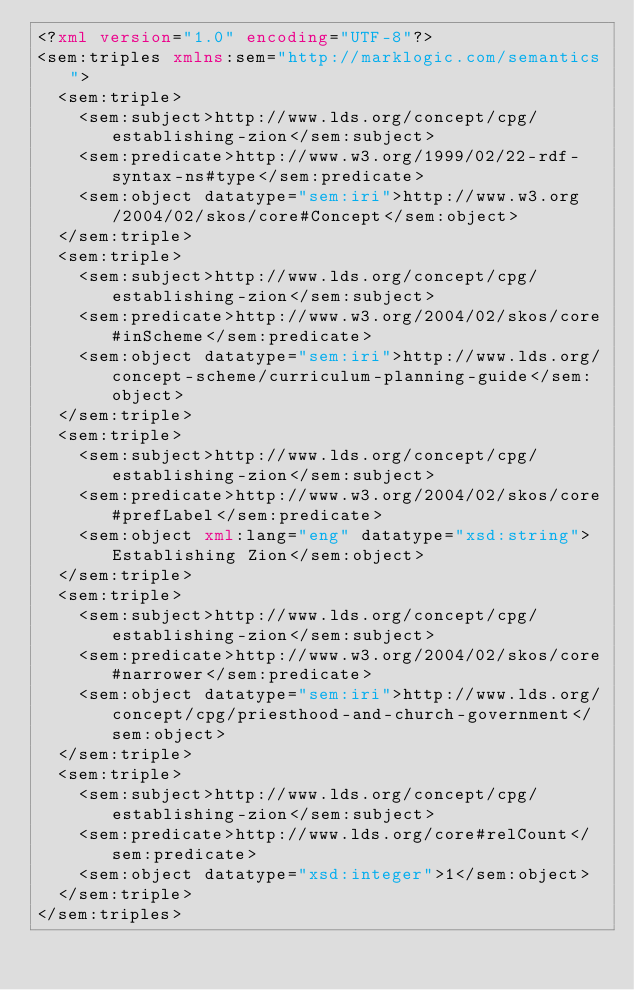<code> <loc_0><loc_0><loc_500><loc_500><_XML_><?xml version="1.0" encoding="UTF-8"?>
<sem:triples xmlns:sem="http://marklogic.com/semantics">
  <sem:triple>
    <sem:subject>http://www.lds.org/concept/cpg/establishing-zion</sem:subject>
    <sem:predicate>http://www.w3.org/1999/02/22-rdf-syntax-ns#type</sem:predicate>
    <sem:object datatype="sem:iri">http://www.w3.org/2004/02/skos/core#Concept</sem:object>
  </sem:triple>
  <sem:triple>
    <sem:subject>http://www.lds.org/concept/cpg/establishing-zion</sem:subject>
    <sem:predicate>http://www.w3.org/2004/02/skos/core#inScheme</sem:predicate>
    <sem:object datatype="sem:iri">http://www.lds.org/concept-scheme/curriculum-planning-guide</sem:object>
  </sem:triple>
  <sem:triple>
    <sem:subject>http://www.lds.org/concept/cpg/establishing-zion</sem:subject>
    <sem:predicate>http://www.w3.org/2004/02/skos/core#prefLabel</sem:predicate>
    <sem:object xml:lang="eng" datatype="xsd:string">Establishing Zion</sem:object>
  </sem:triple>
  <sem:triple>
    <sem:subject>http://www.lds.org/concept/cpg/establishing-zion</sem:subject>
    <sem:predicate>http://www.w3.org/2004/02/skos/core#narrower</sem:predicate>
    <sem:object datatype="sem:iri">http://www.lds.org/concept/cpg/priesthood-and-church-government</sem:object>
  </sem:triple>
  <sem:triple>
    <sem:subject>http://www.lds.org/concept/cpg/establishing-zion</sem:subject>
    <sem:predicate>http://www.lds.org/core#relCount</sem:predicate>
    <sem:object datatype="xsd:integer">1</sem:object>
  </sem:triple>
</sem:triples>
</code> 